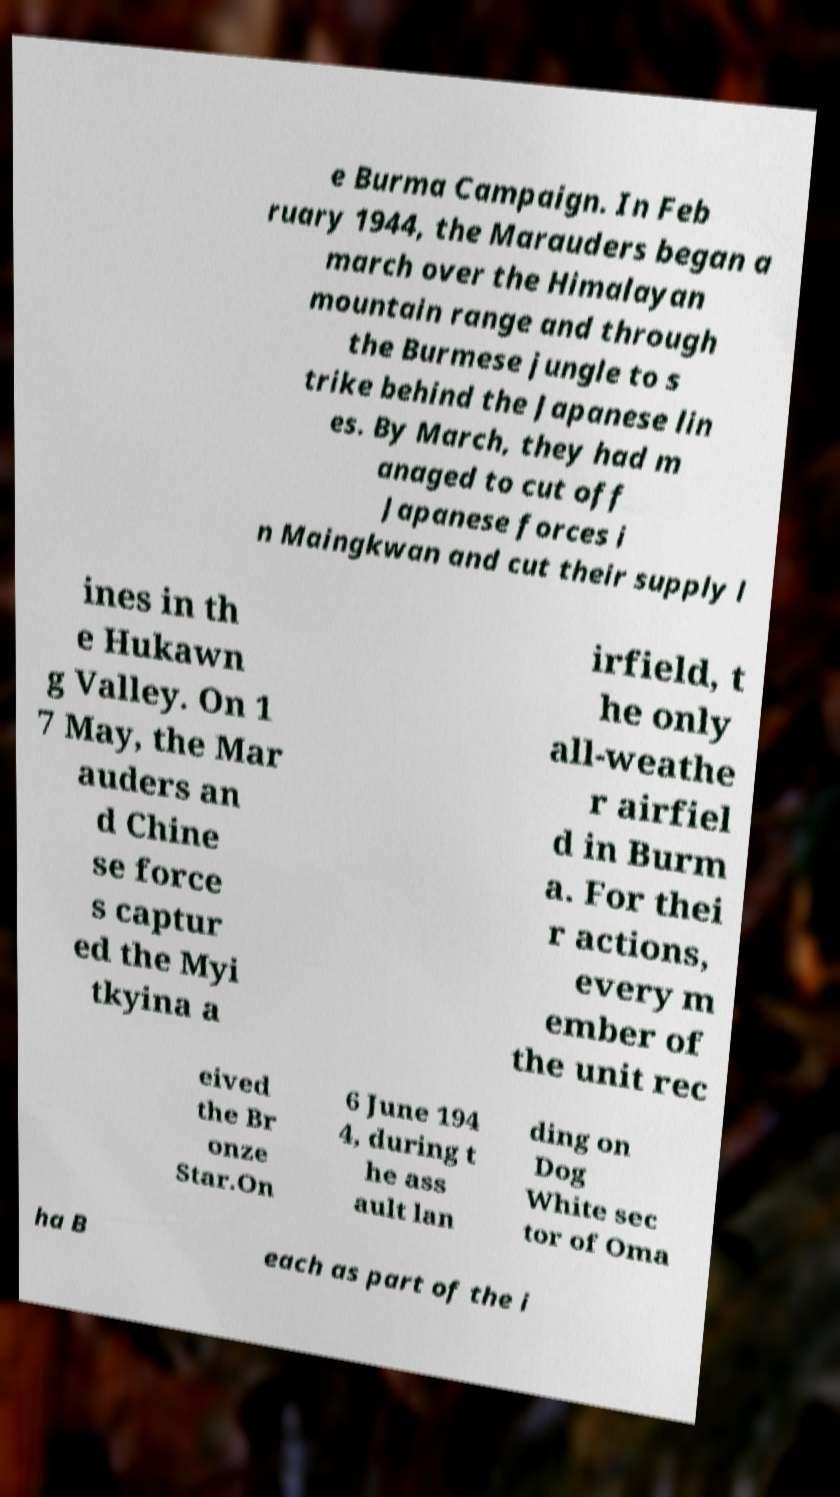Could you assist in decoding the text presented in this image and type it out clearly? e Burma Campaign. In Feb ruary 1944, the Marauders began a march over the Himalayan mountain range and through the Burmese jungle to s trike behind the Japanese lin es. By March, they had m anaged to cut off Japanese forces i n Maingkwan and cut their supply l ines in th e Hukawn g Valley. On 1 7 May, the Mar auders an d Chine se force s captur ed the Myi tkyina a irfield, t he only all-weathe r airfiel d in Burm a. For thei r actions, every m ember of the unit rec eived the Br onze Star.On 6 June 194 4, during t he ass ault lan ding on Dog White sec tor of Oma ha B each as part of the i 